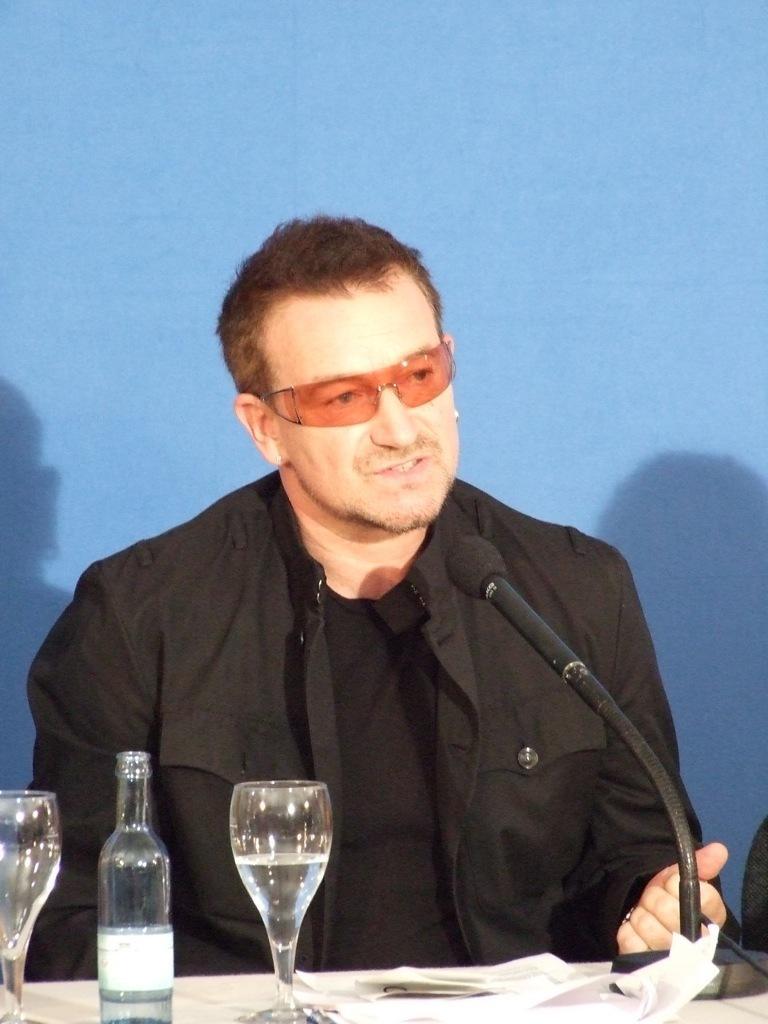Can you describe this image briefly? Here we can see a man sitting on a chair and speaking in the microphone present in front of him on the table and there is a bottle and glass of water present 